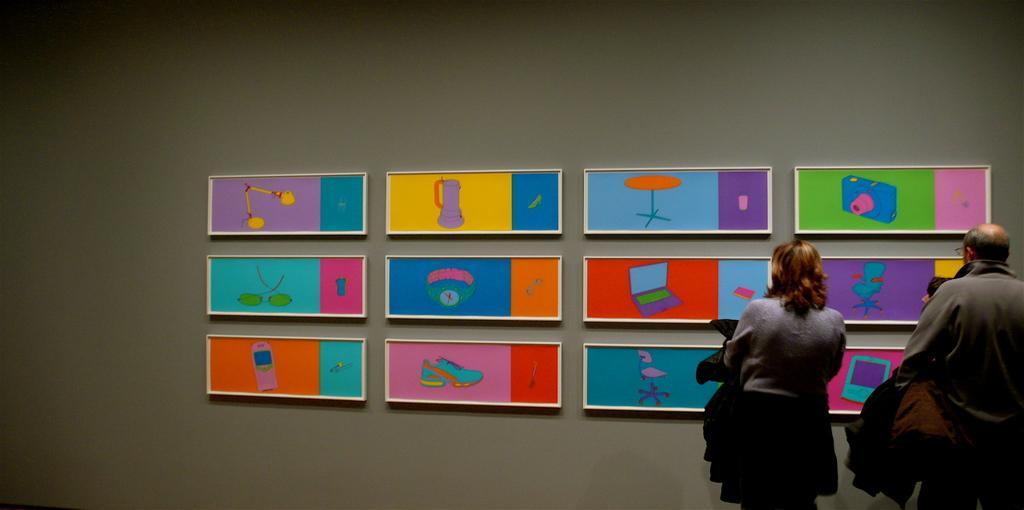Can you describe this image briefly? In this picture I can observe number of arts on the wall. On the right side there are two members standing in front of these arts. The wall is in grey color. 